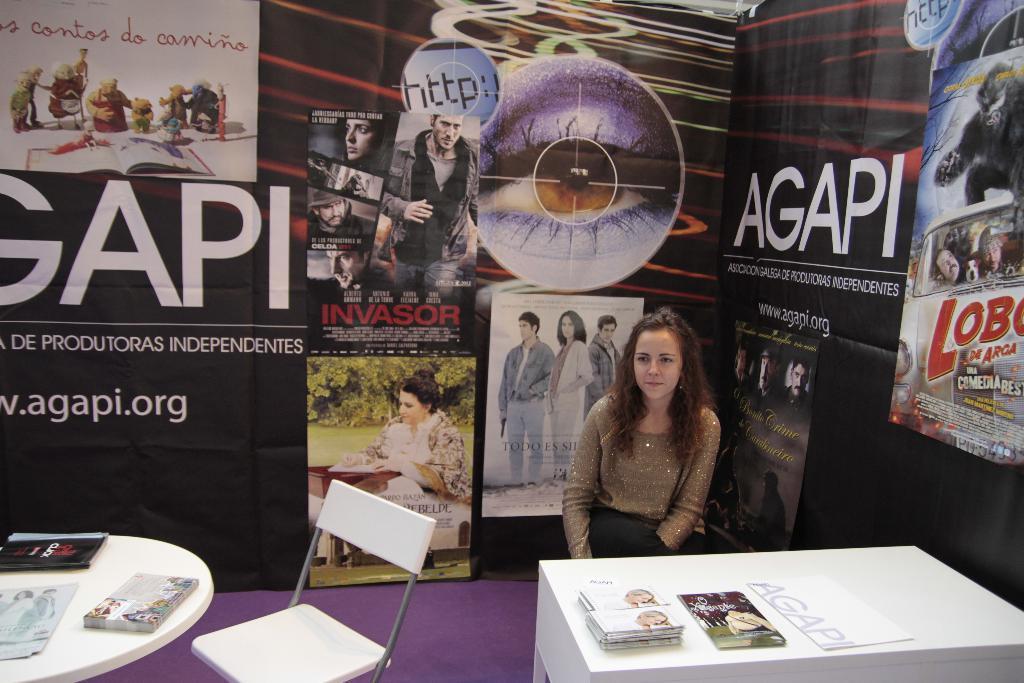Describe this image in one or two sentences. In this image I can see a chair,table. On the table there are books. At the back side there is a banner. 